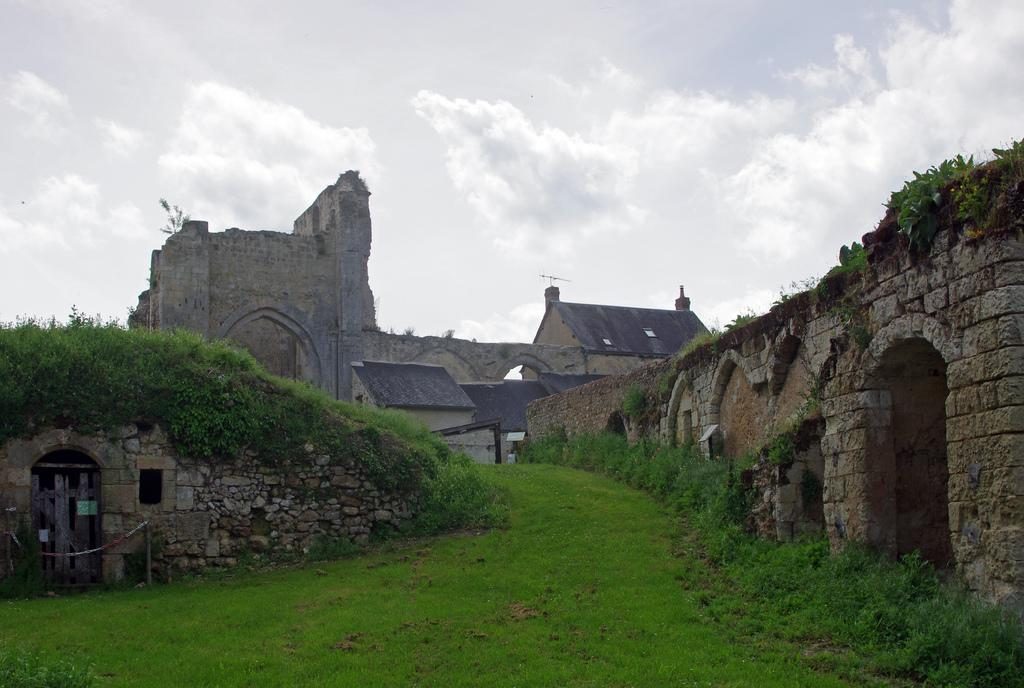What can be seen in the center of the image? The sky is visible in the center of the image. What is present in the sky? Clouds are present in the image. What type of vegetation is visible in the image? Grass is visible in the image. What architectural features can be seen in the image? There are arches in the image. What type of structure is present in the image? A fort is present in the image. How many trucks are visible in the image? There are no trucks present in the image. 